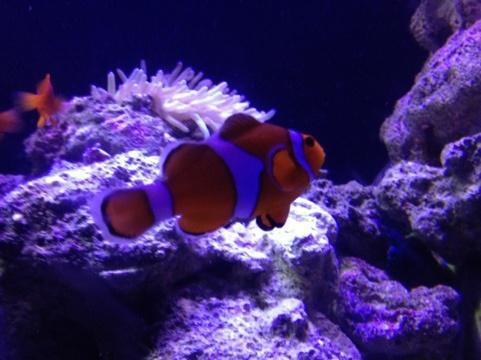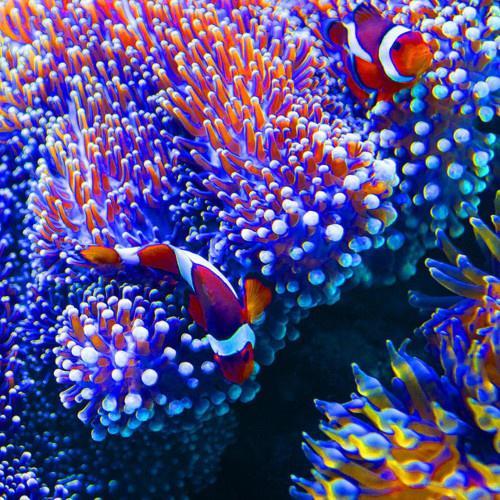The first image is the image on the left, the second image is the image on the right. Considering the images on both sides, is "An image shows exactly two clown fish swimming by a neutral-colored anemone." valid? Answer yes or no. No. The first image is the image on the left, the second image is the image on the right. Analyze the images presented: Is the assertion "There are two clown fish in total." valid? Answer yes or no. No. 